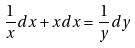<formula> <loc_0><loc_0><loc_500><loc_500>\frac { 1 } { x } d x + x d x = \frac { 1 } { y } d y</formula> 